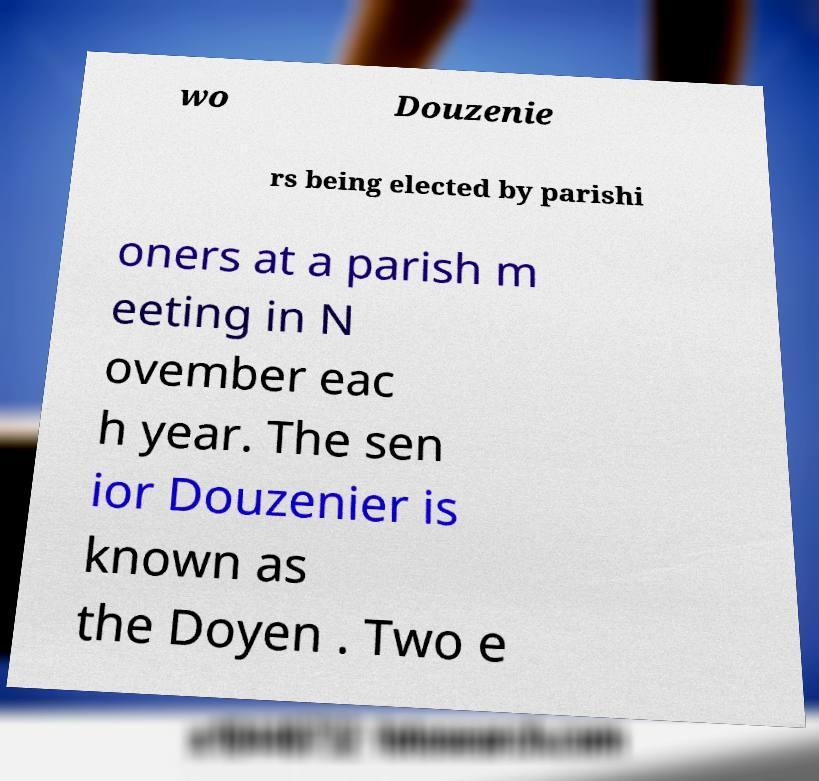Can you accurately transcribe the text from the provided image for me? wo Douzenie rs being elected by parishi oners at a parish m eeting in N ovember eac h year. The sen ior Douzenier is known as the Doyen . Two e 